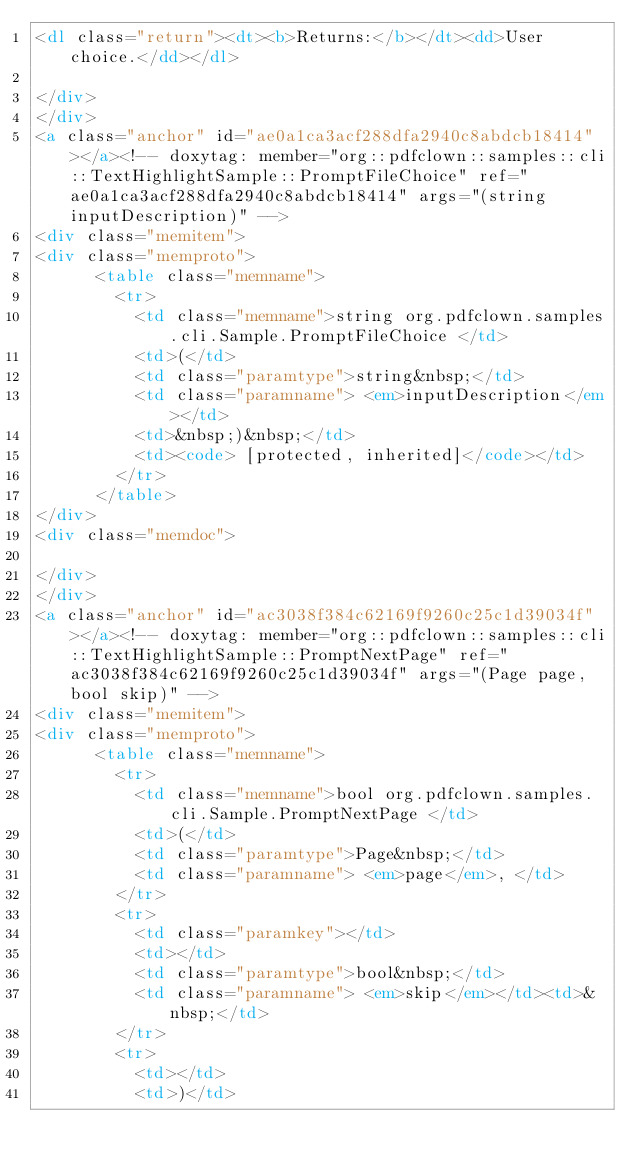Convert code to text. <code><loc_0><loc_0><loc_500><loc_500><_HTML_><dl class="return"><dt><b>Returns:</b></dt><dd>User choice.</dd></dl>

</div>
</div>
<a class="anchor" id="ae0a1ca3acf288dfa2940c8abdcb18414"></a><!-- doxytag: member="org::pdfclown::samples::cli::TextHighlightSample::PromptFileChoice" ref="ae0a1ca3acf288dfa2940c8abdcb18414" args="(string inputDescription)" -->
<div class="memitem">
<div class="memproto">
      <table class="memname">
        <tr>
          <td class="memname">string org.pdfclown.samples.cli.Sample.PromptFileChoice </td>
          <td>(</td>
          <td class="paramtype">string&nbsp;</td>
          <td class="paramname"> <em>inputDescription</em></td>
          <td>&nbsp;)&nbsp;</td>
          <td><code> [protected, inherited]</code></td>
        </tr>
      </table>
</div>
<div class="memdoc">

</div>
</div>
<a class="anchor" id="ac3038f384c62169f9260c25c1d39034f"></a><!-- doxytag: member="org::pdfclown::samples::cli::TextHighlightSample::PromptNextPage" ref="ac3038f384c62169f9260c25c1d39034f" args="(Page page, bool skip)" -->
<div class="memitem">
<div class="memproto">
      <table class="memname">
        <tr>
          <td class="memname">bool org.pdfclown.samples.cli.Sample.PromptNextPage </td>
          <td>(</td>
          <td class="paramtype">Page&nbsp;</td>
          <td class="paramname"> <em>page</em>, </td>
        </tr>
        <tr>
          <td class="paramkey"></td>
          <td></td>
          <td class="paramtype">bool&nbsp;</td>
          <td class="paramname"> <em>skip</em></td><td>&nbsp;</td>
        </tr>
        <tr>
          <td></td>
          <td>)</td></code> 